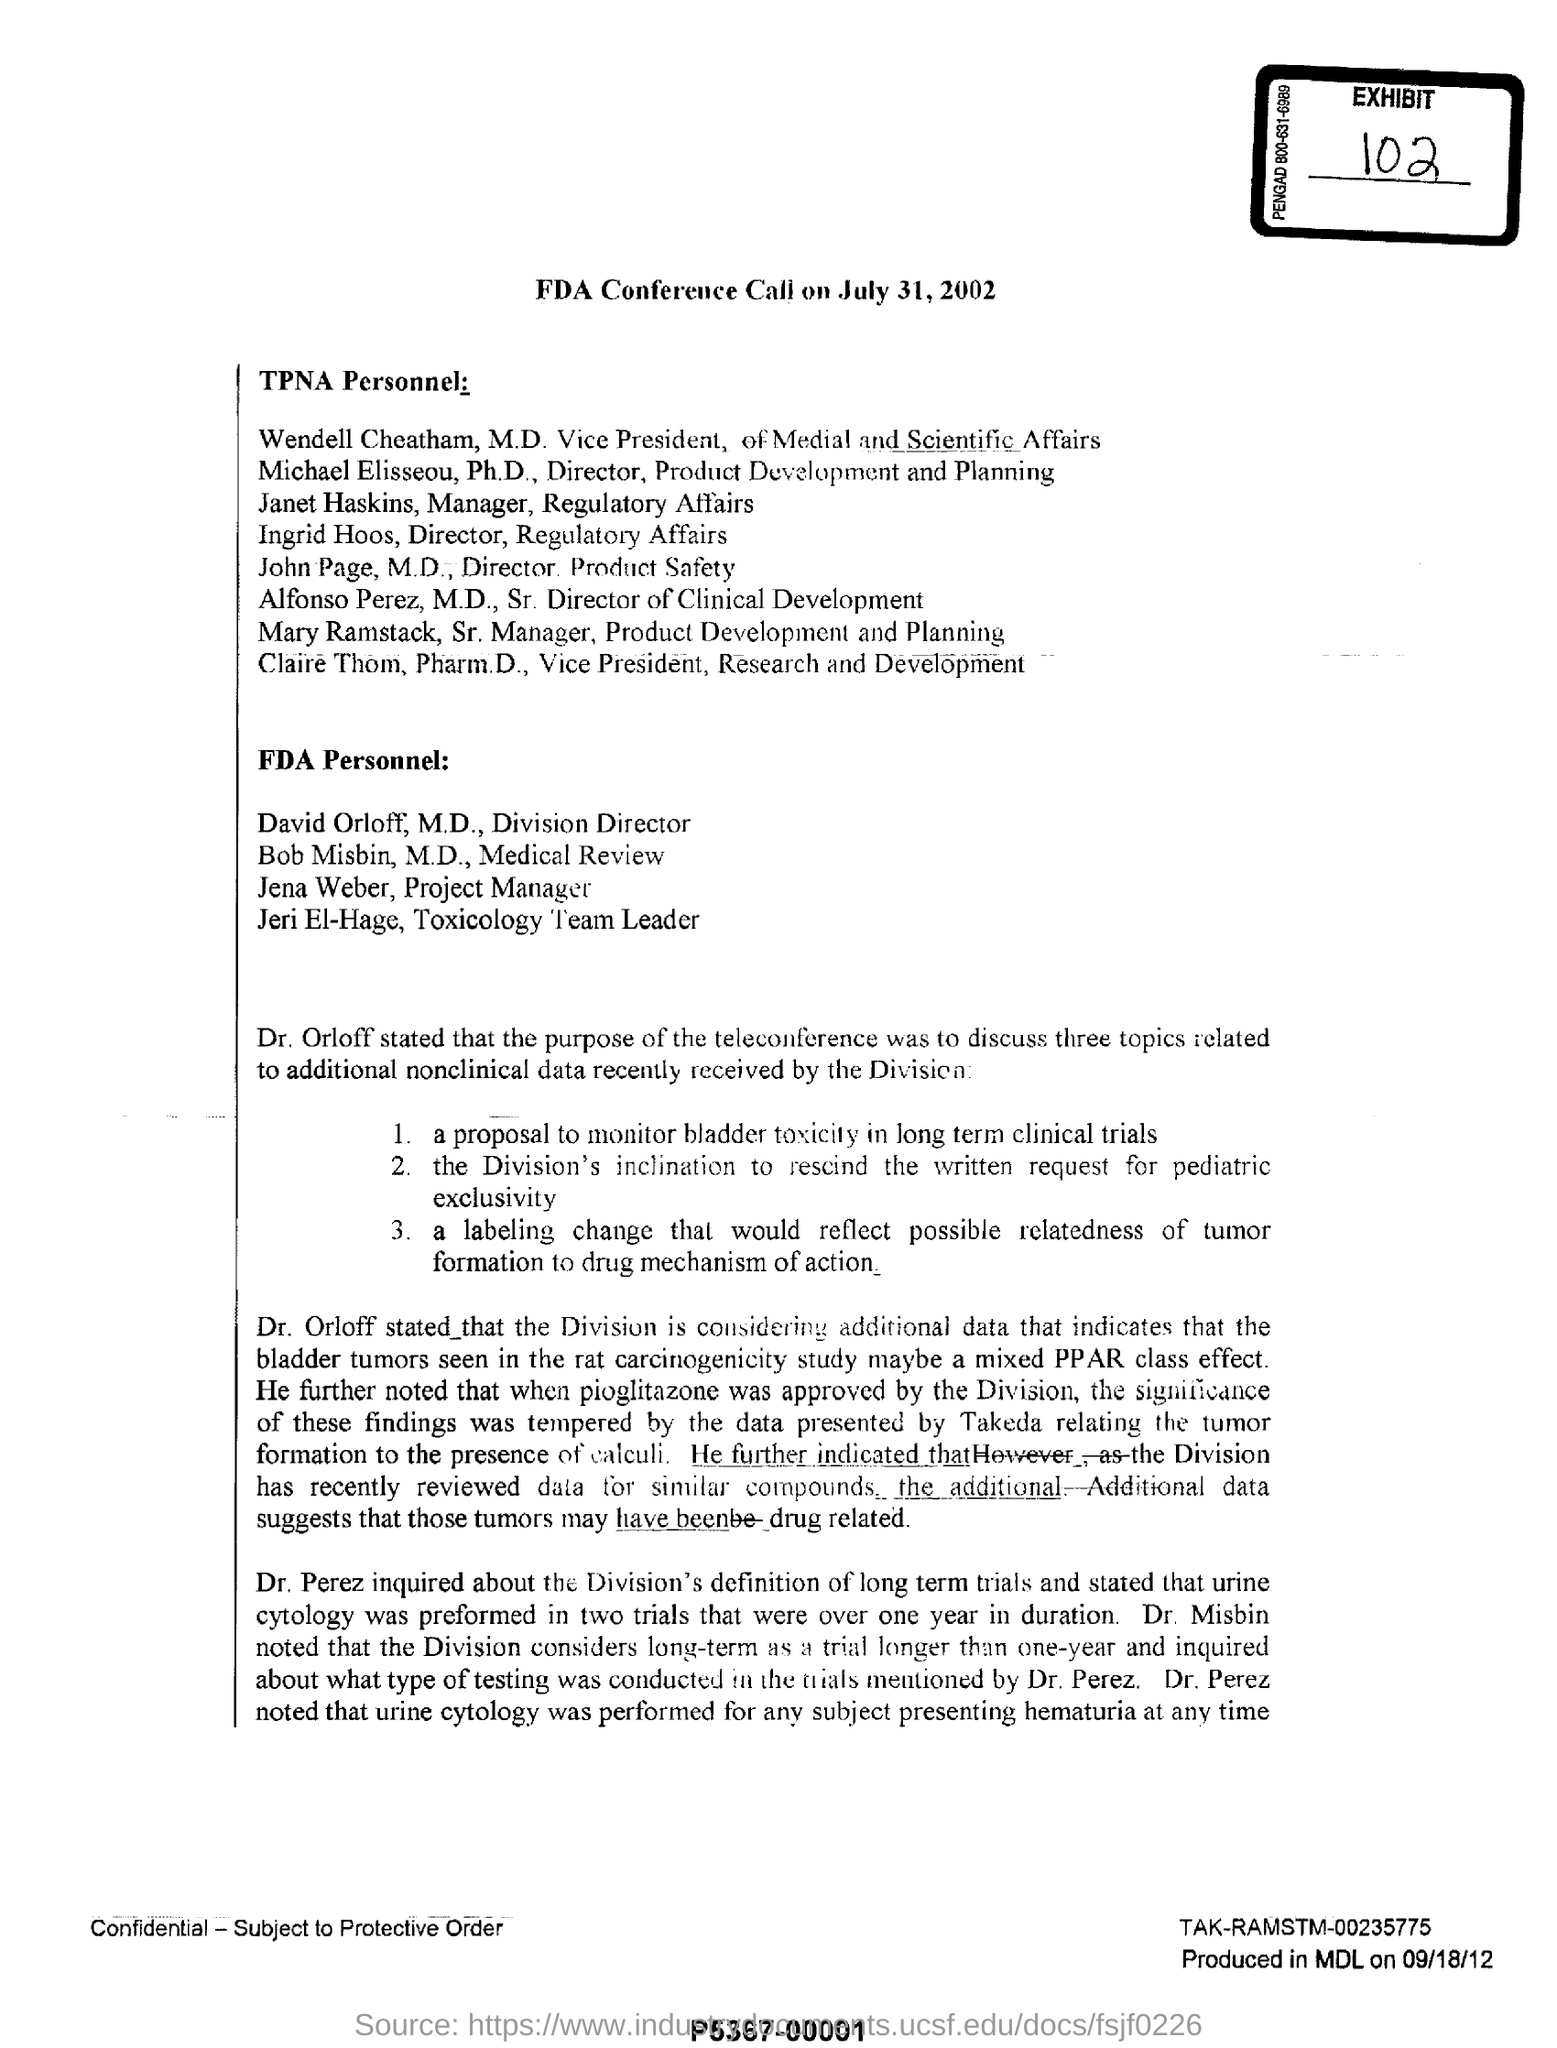Outline some significant characteristics in this image. The FDA conference call will be held on July 31, 2002. The purpose of the teleconference was to discuss three topics. The date mentioned at the bottom of the document is September 18, 2012. 